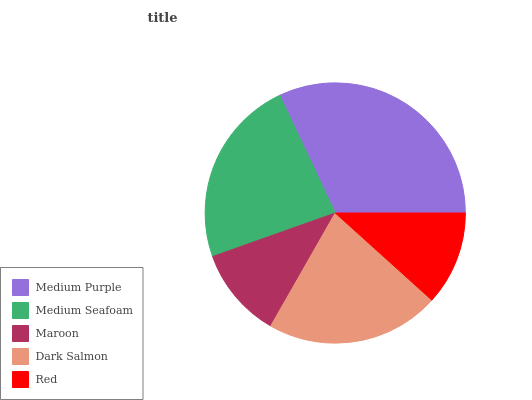Is Maroon the minimum?
Answer yes or no. Yes. Is Medium Purple the maximum?
Answer yes or no. Yes. Is Medium Seafoam the minimum?
Answer yes or no. No. Is Medium Seafoam the maximum?
Answer yes or no. No. Is Medium Purple greater than Medium Seafoam?
Answer yes or no. Yes. Is Medium Seafoam less than Medium Purple?
Answer yes or no. Yes. Is Medium Seafoam greater than Medium Purple?
Answer yes or no. No. Is Medium Purple less than Medium Seafoam?
Answer yes or no. No. Is Dark Salmon the high median?
Answer yes or no. Yes. Is Dark Salmon the low median?
Answer yes or no. Yes. Is Red the high median?
Answer yes or no. No. Is Red the low median?
Answer yes or no. No. 